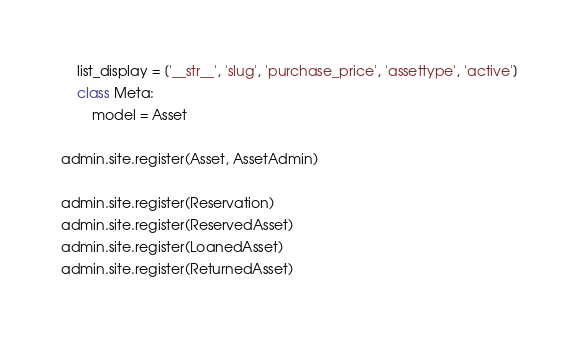Convert code to text. <code><loc_0><loc_0><loc_500><loc_500><_Python_>    list_display = ['__str__', 'slug', 'purchase_price', 'assettype', 'active']
    class Meta:
        model = Asset

admin.site.register(Asset, AssetAdmin)

admin.site.register(Reservation)
admin.site.register(ReservedAsset)
admin.site.register(LoanedAsset)
admin.site.register(ReturnedAsset)
</code> 